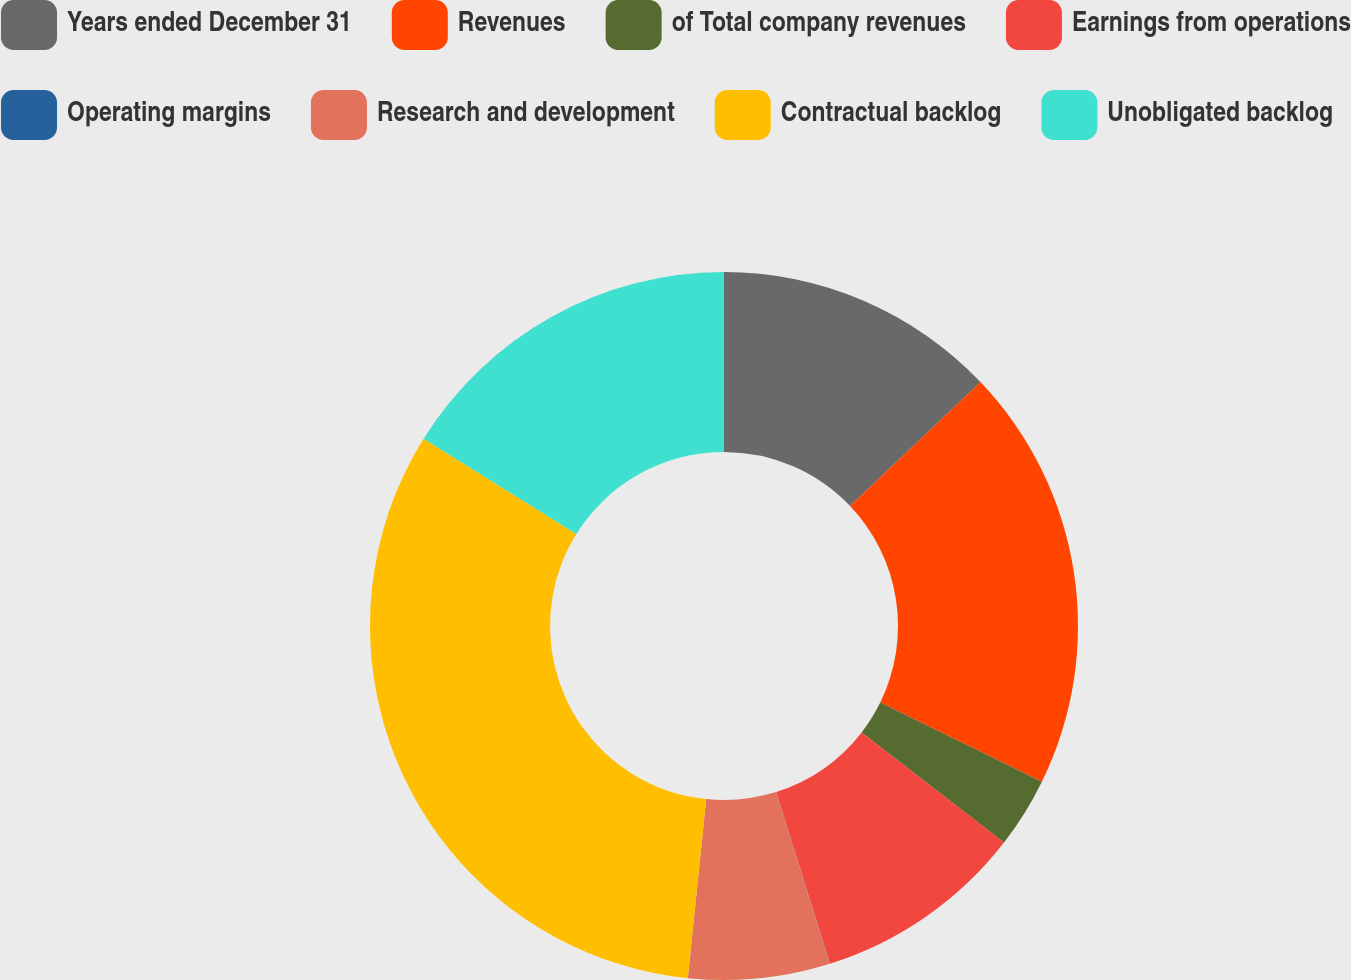<chart> <loc_0><loc_0><loc_500><loc_500><pie_chart><fcel>Years ended December 31<fcel>Revenues<fcel>of Total company revenues<fcel>Earnings from operations<fcel>Operating margins<fcel>Research and development<fcel>Contractual backlog<fcel>Unobligated backlog<nl><fcel>12.9%<fcel>19.35%<fcel>3.23%<fcel>9.68%<fcel>0.01%<fcel>6.46%<fcel>32.24%<fcel>16.13%<nl></chart> 